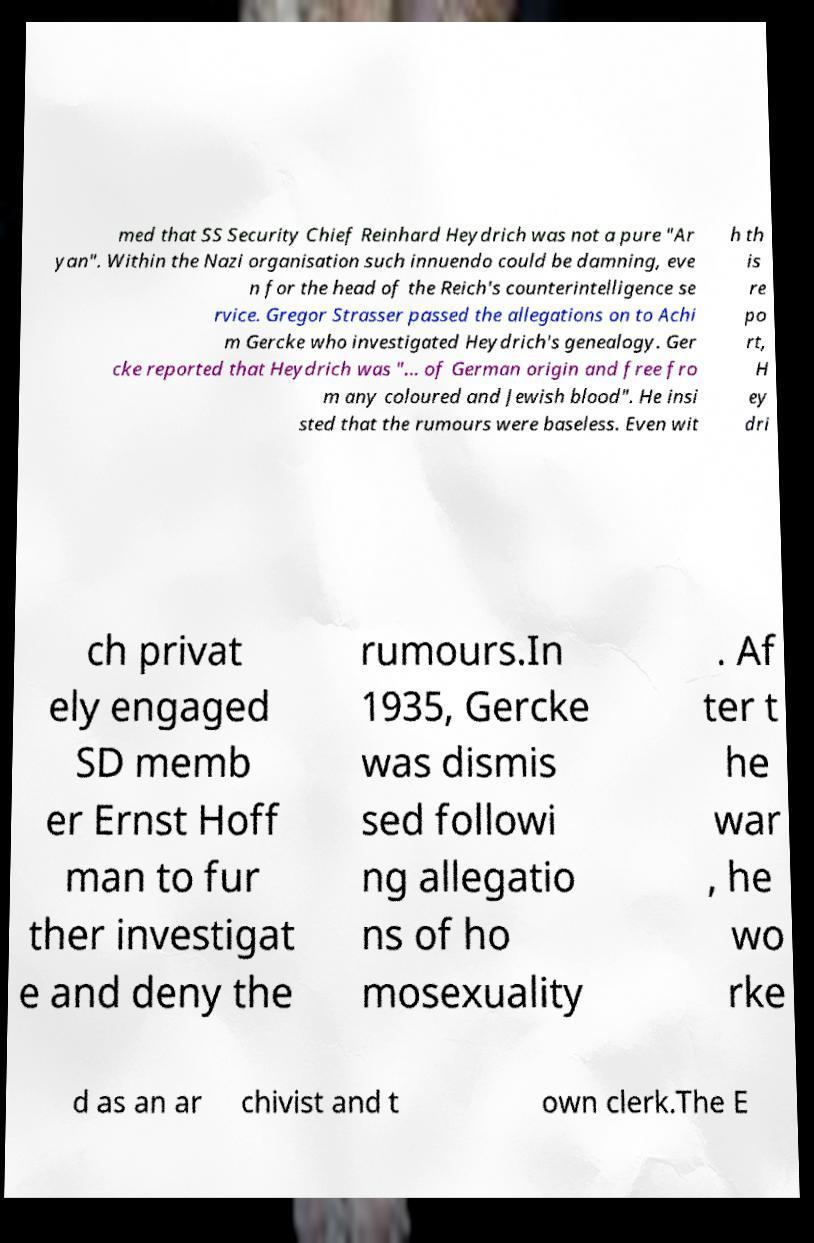Please read and relay the text visible in this image. What does it say? med that SS Security Chief Reinhard Heydrich was not a pure "Ar yan". Within the Nazi organisation such innuendo could be damning, eve n for the head of the Reich's counterintelligence se rvice. Gregor Strasser passed the allegations on to Achi m Gercke who investigated Heydrich's genealogy. Ger cke reported that Heydrich was "... of German origin and free fro m any coloured and Jewish blood". He insi sted that the rumours were baseless. Even wit h th is re po rt, H ey dri ch privat ely engaged SD memb er Ernst Hoff man to fur ther investigat e and deny the rumours.In 1935, Gercke was dismis sed followi ng allegatio ns of ho mosexuality . Af ter t he war , he wo rke d as an ar chivist and t own clerk.The E 